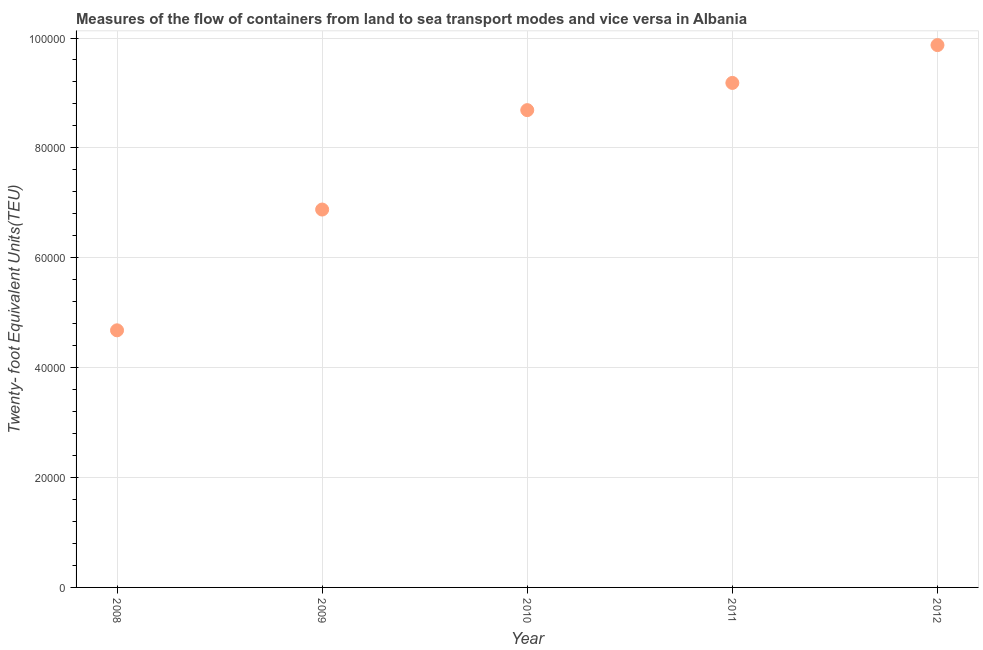What is the container port traffic in 2011?
Keep it short and to the point. 9.18e+04. Across all years, what is the maximum container port traffic?
Provide a succinct answer. 9.87e+04. Across all years, what is the minimum container port traffic?
Make the answer very short. 4.68e+04. In which year was the container port traffic minimum?
Make the answer very short. 2008. What is the sum of the container port traffic?
Offer a very short reply. 3.93e+05. What is the difference between the container port traffic in 2008 and 2012?
Provide a short and direct response. -5.19e+04. What is the average container port traffic per year?
Offer a very short reply. 7.86e+04. What is the median container port traffic?
Your answer should be compact. 8.69e+04. What is the ratio of the container port traffic in 2009 to that in 2010?
Ensure brevity in your answer.  0.79. Is the container port traffic in 2010 less than that in 2011?
Provide a short and direct response. Yes. What is the difference between the highest and the second highest container port traffic?
Make the answer very short. 6887.02. Is the sum of the container port traffic in 2008 and 2011 greater than the maximum container port traffic across all years?
Your answer should be compact. Yes. What is the difference between the highest and the lowest container port traffic?
Provide a succinct answer. 5.19e+04. In how many years, is the container port traffic greater than the average container port traffic taken over all years?
Make the answer very short. 3. What is the difference between two consecutive major ticks on the Y-axis?
Your answer should be very brief. 2.00e+04. Does the graph contain any zero values?
Offer a terse response. No. What is the title of the graph?
Offer a very short reply. Measures of the flow of containers from land to sea transport modes and vice versa in Albania. What is the label or title of the Y-axis?
Your response must be concise. Twenty- foot Equivalent Units(TEU). What is the Twenty- foot Equivalent Units(TEU) in 2008?
Ensure brevity in your answer.  4.68e+04. What is the Twenty- foot Equivalent Units(TEU) in 2009?
Keep it short and to the point. 6.88e+04. What is the Twenty- foot Equivalent Units(TEU) in 2010?
Your response must be concise. 8.69e+04. What is the Twenty- foot Equivalent Units(TEU) in 2011?
Make the answer very short. 9.18e+04. What is the Twenty- foot Equivalent Units(TEU) in 2012?
Make the answer very short. 9.87e+04. What is the difference between the Twenty- foot Equivalent Units(TEU) in 2008 and 2009?
Your answer should be compact. -2.20e+04. What is the difference between the Twenty- foot Equivalent Units(TEU) in 2008 and 2010?
Offer a terse response. -4.01e+04. What is the difference between the Twenty- foot Equivalent Units(TEU) in 2008 and 2011?
Your response must be concise. -4.50e+04. What is the difference between the Twenty- foot Equivalent Units(TEU) in 2008 and 2012?
Your answer should be compact. -5.19e+04. What is the difference between the Twenty- foot Equivalent Units(TEU) in 2009 and 2010?
Ensure brevity in your answer.  -1.81e+04. What is the difference between the Twenty- foot Equivalent Units(TEU) in 2009 and 2011?
Provide a short and direct response. -2.30e+04. What is the difference between the Twenty- foot Equivalent Units(TEU) in 2009 and 2012?
Provide a succinct answer. -2.99e+04. What is the difference between the Twenty- foot Equivalent Units(TEU) in 2010 and 2011?
Provide a short and direct response. -4951.88. What is the difference between the Twenty- foot Equivalent Units(TEU) in 2010 and 2012?
Your answer should be very brief. -1.18e+04. What is the difference between the Twenty- foot Equivalent Units(TEU) in 2011 and 2012?
Make the answer very short. -6887.02. What is the ratio of the Twenty- foot Equivalent Units(TEU) in 2008 to that in 2009?
Keep it short and to the point. 0.68. What is the ratio of the Twenty- foot Equivalent Units(TEU) in 2008 to that in 2010?
Ensure brevity in your answer.  0.54. What is the ratio of the Twenty- foot Equivalent Units(TEU) in 2008 to that in 2011?
Give a very brief answer. 0.51. What is the ratio of the Twenty- foot Equivalent Units(TEU) in 2008 to that in 2012?
Your response must be concise. 0.47. What is the ratio of the Twenty- foot Equivalent Units(TEU) in 2009 to that in 2010?
Provide a short and direct response. 0.79. What is the ratio of the Twenty- foot Equivalent Units(TEU) in 2009 to that in 2011?
Keep it short and to the point. 0.75. What is the ratio of the Twenty- foot Equivalent Units(TEU) in 2009 to that in 2012?
Make the answer very short. 0.7. What is the ratio of the Twenty- foot Equivalent Units(TEU) in 2010 to that in 2011?
Make the answer very short. 0.95. What is the ratio of the Twenty- foot Equivalent Units(TEU) in 2011 to that in 2012?
Your response must be concise. 0.93. 